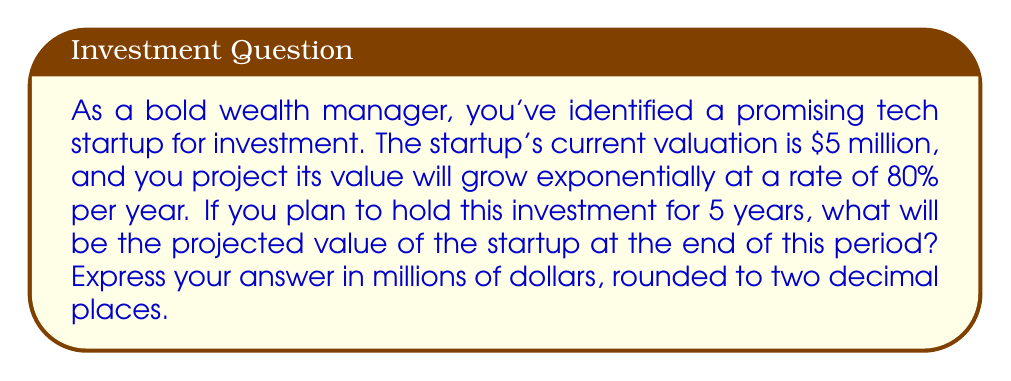Can you answer this question? To solve this problem, we'll use the exponential growth model:

$$A = P(1 + r)^t$$

Where:
$A$ = Final amount
$P$ = Initial principal (starting value)
$r$ = Growth rate (as a decimal)
$t$ = Time period

Given:
$P = 5$ million dollars
$r = 0.80$ (80% expressed as a decimal)
$t = 5$ years

Let's substitute these values into our equation:

$$A = 5(1 + 0.80)^5$$

Now, let's solve step by step:

1) First, calculate $(1 + 0.80)$:
   $$(1 + 0.80) = 1.80$$

2) Now, we have:
   $$A = 5(1.80)^5$$

3) Calculate $1.80^5$:
   $$1.80^5 = 18.8928$$

4) Finally, multiply by 5:
   $$A = 5 * 18.8928 = 94.464$$

Therefore, the projected value after 5 years is $94.464 million.

Rounding to two decimal places gives us $94.46 million.
Answer: $94.46 million 